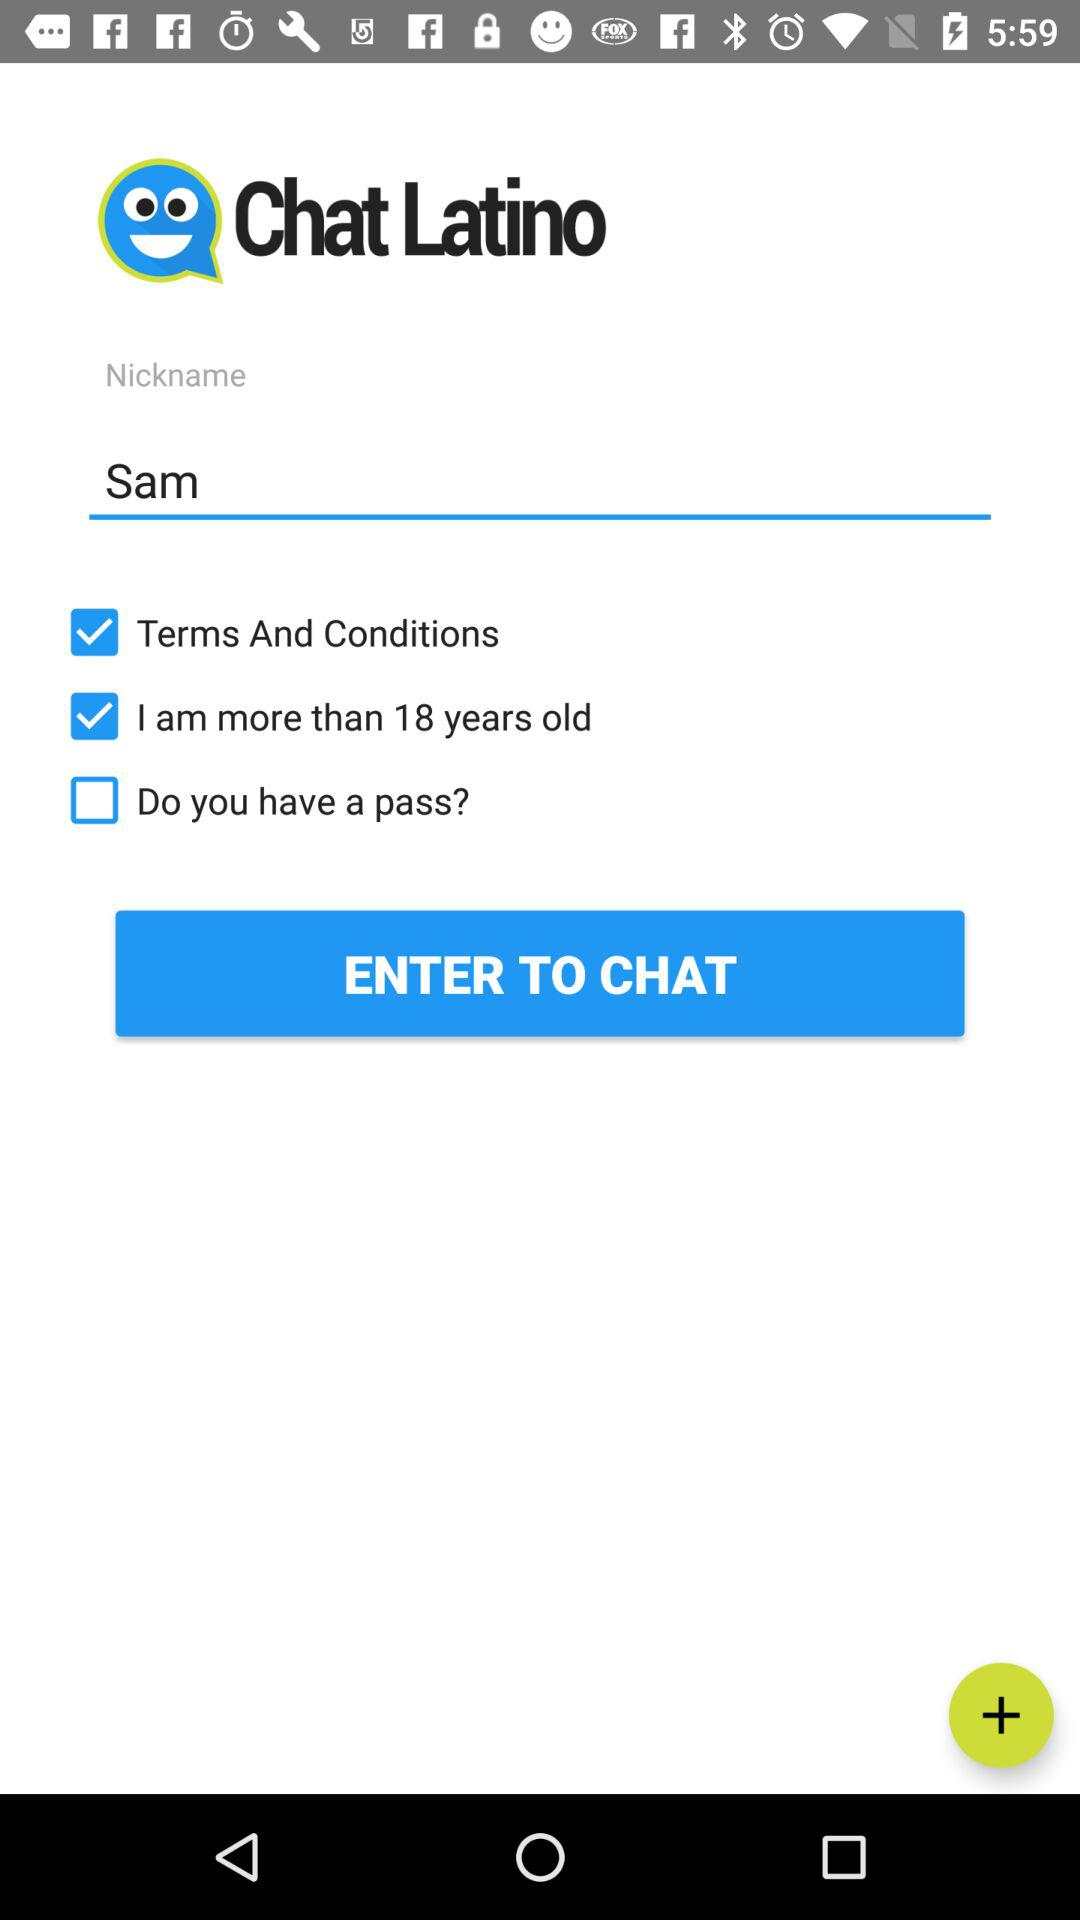What is the name of the user? The name of the user is Sam. 